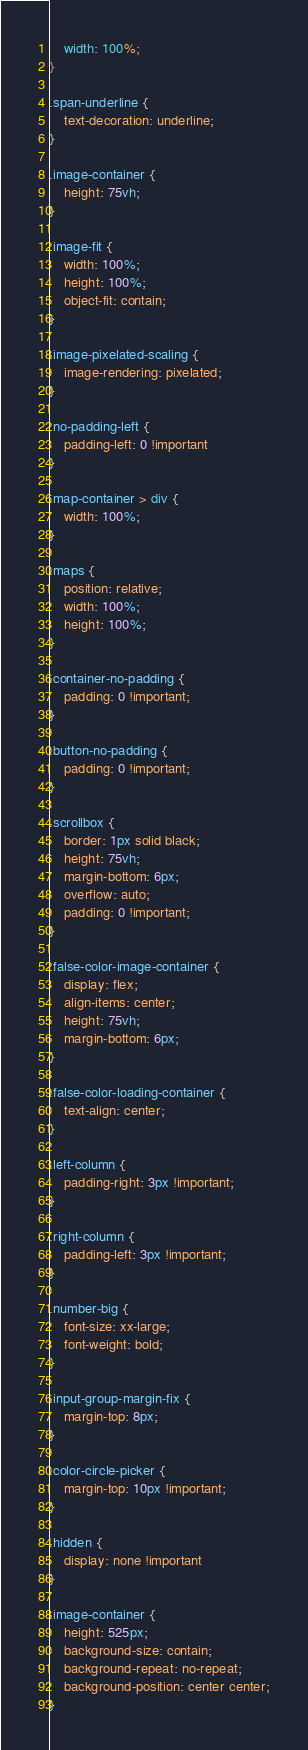<code> <loc_0><loc_0><loc_500><loc_500><_CSS_>    width: 100%;
}

.span-underline {
    text-decoration: underline;
}

.image-container {
    height: 75vh;
}

.image-fit {
    width: 100%;
    height: 100%;
    object-fit: contain;
}

.image-pixelated-scaling {
    image-rendering: pixelated;
}

.no-padding-left {
    padding-left: 0 !important
}

.map-container > div {
    width: 100%;
}

.maps {
    position: relative;
    width: 100%;
    height: 100%;
}

.container-no-padding {
    padding: 0 !important;
}

.button-no-padding {
    padding: 0 !important;
}

.scrollbox {
    border: 1px solid black;
    height: 75vh;
    margin-bottom: 6px;
    overflow: auto;
    padding: 0 !important;
}

.false-color-image-container {
    display: flex;
    align-items: center;
    height: 75vh;
    margin-bottom: 6px;
}

.false-color-loading-container {
    text-align: center;
}

.left-column {
    padding-right: 3px !important;
}

.right-column {
    padding-left: 3px !important;
}

.number-big {
    font-size: xx-large;
    font-weight: bold;
}

.input-group-margin-fix {
    margin-top: 8px;
}

.color-circle-picker {
    margin-top: 10px !important;
}

.hidden {
    display: none !important
}

.image-container {
    height: 525px;
    background-size: contain;
    background-repeat: no-repeat;
    background-position: center center;
}</code> 